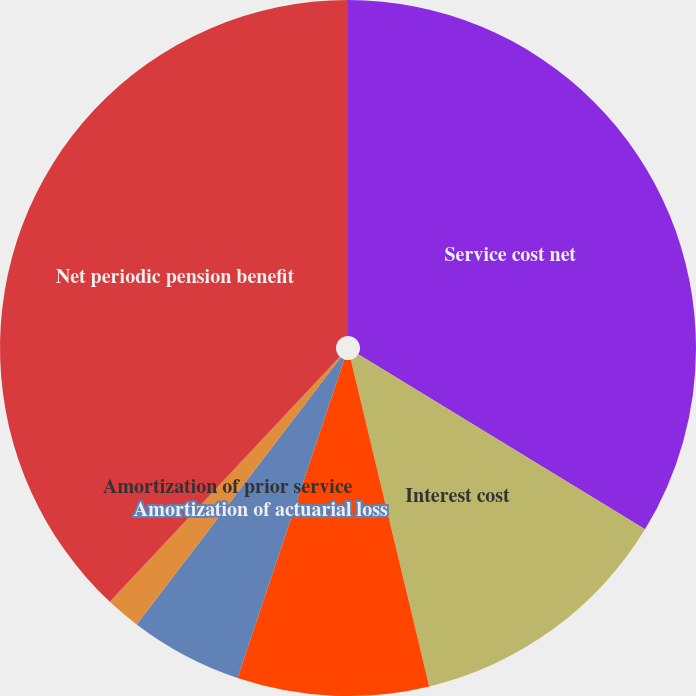Convert chart. <chart><loc_0><loc_0><loc_500><loc_500><pie_chart><fcel>Service cost net<fcel>Interest cost<fcel>Expected return on plan assets<fcel>Amortization of actuarial loss<fcel>Amortization of prior service<fcel>Net periodic pension benefit<nl><fcel>33.73%<fcel>12.53%<fcel>8.89%<fcel>5.25%<fcel>1.61%<fcel>38.01%<nl></chart> 